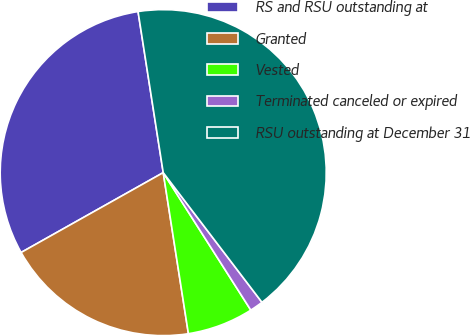Convert chart to OTSL. <chart><loc_0><loc_0><loc_500><loc_500><pie_chart><fcel>RS and RSU outstanding at<fcel>Granted<fcel>Vested<fcel>Terminated canceled or expired<fcel>RSU outstanding at December 31<nl><fcel>30.68%<fcel>19.32%<fcel>6.56%<fcel>1.33%<fcel>42.11%<nl></chart> 